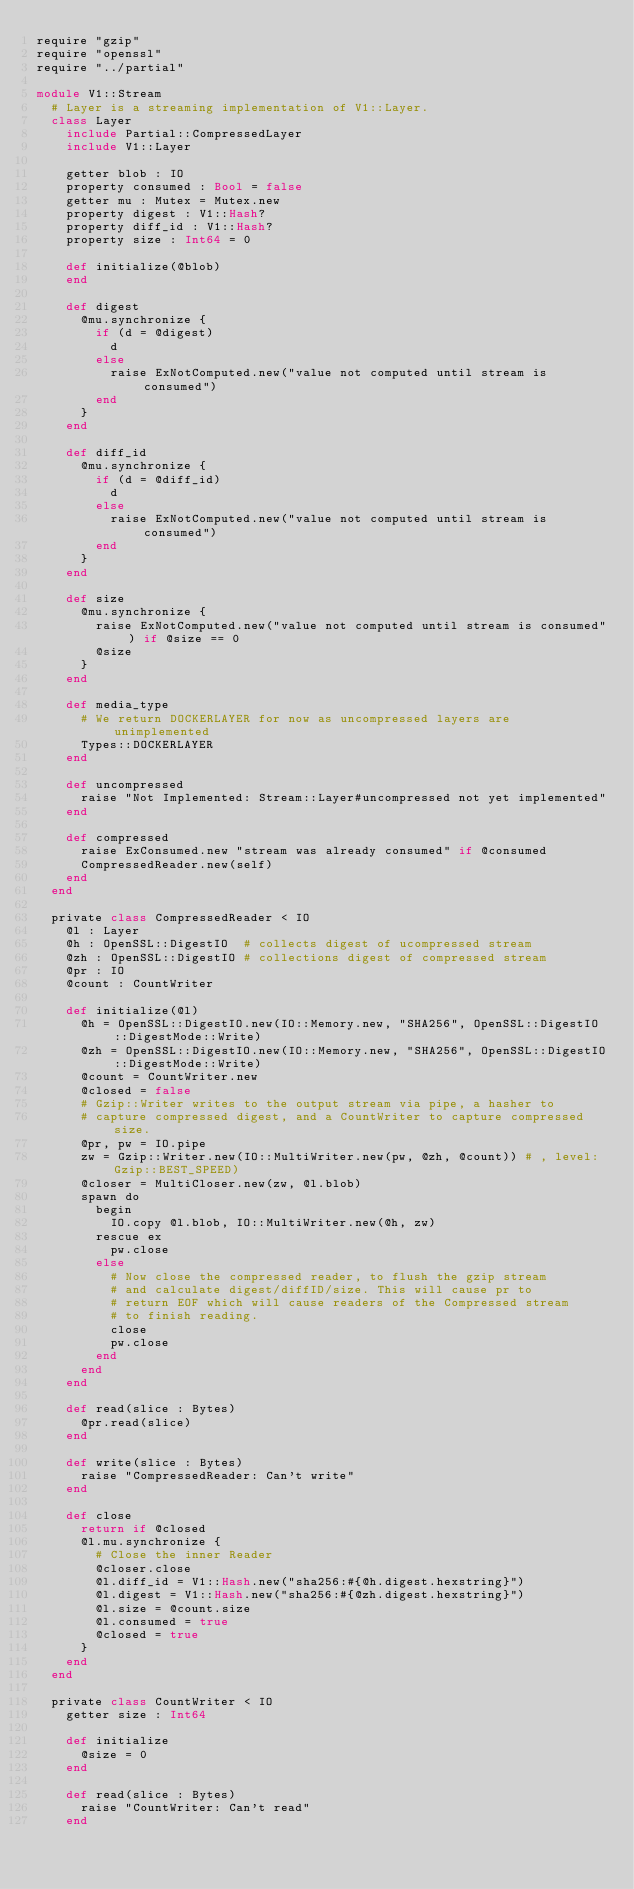Convert code to text. <code><loc_0><loc_0><loc_500><loc_500><_Crystal_>require "gzip"
require "openssl"
require "../partial"

module V1::Stream
  # Layer is a streaming implementation of V1::Layer.
  class Layer
    include Partial::CompressedLayer
    include V1::Layer

    getter blob : IO
    property consumed : Bool = false
    getter mu : Mutex = Mutex.new
    property digest : V1::Hash?
    property diff_id : V1::Hash?
    property size : Int64 = 0

    def initialize(@blob)
    end

    def digest
      @mu.synchronize {
        if (d = @digest)
          d
        else
          raise ExNotComputed.new("value not computed until stream is consumed")
        end
      }
    end

    def diff_id
      @mu.synchronize {
        if (d = @diff_id)
          d
        else
          raise ExNotComputed.new("value not computed until stream is consumed")
        end
      }
    end

    def size
      @mu.synchronize {
        raise ExNotComputed.new("value not computed until stream is consumed") if @size == 0
        @size
      }
    end

    def media_type
      # We return DOCKERLAYER for now as uncompressed layers are unimplemented
      Types::DOCKERLAYER
    end

    def uncompressed
      raise "Not Implemented: Stream::Layer#uncompressed not yet implemented"
    end

    def compressed
      raise ExConsumed.new "stream was already consumed" if @consumed
      CompressedReader.new(self)
    end
  end

  private class CompressedReader < IO
    @l : Layer
    @h : OpenSSL::DigestIO  # collects digest of ucompressed stream
    @zh : OpenSSL::DigestIO # collections digest of compressed stream
    @pr : IO
    @count : CountWriter

    def initialize(@l)
      @h = OpenSSL::DigestIO.new(IO::Memory.new, "SHA256", OpenSSL::DigestIO::DigestMode::Write)
      @zh = OpenSSL::DigestIO.new(IO::Memory.new, "SHA256", OpenSSL::DigestIO::DigestMode::Write)
      @count = CountWriter.new
      @closed = false
      # Gzip::Writer writes to the output stream via pipe, a hasher to
      # capture compressed digest, and a CountWriter to capture compressed size.
      @pr, pw = IO.pipe
      zw = Gzip::Writer.new(IO::MultiWriter.new(pw, @zh, @count)) # , level: Gzip::BEST_SPEED)
      @closer = MultiCloser.new(zw, @l.blob)
      spawn do
        begin
          IO.copy @l.blob, IO::MultiWriter.new(@h, zw)
        rescue ex
          pw.close
        else
          # Now close the compressed reader, to flush the gzip stream
          # and calculate digest/diffID/size. This will cause pr to
          # return EOF which will cause readers of the Compressed stream
          # to finish reading.
          close
          pw.close
        end
      end
    end

    def read(slice : Bytes)
      @pr.read(slice)
    end

    def write(slice : Bytes)
      raise "CompressedReader: Can't write"
    end

    def close
      return if @closed
      @l.mu.synchronize {
        # Close the inner Reader
        @closer.close
        @l.diff_id = V1::Hash.new("sha256:#{@h.digest.hexstring}")
        @l.digest = V1::Hash.new("sha256:#{@zh.digest.hexstring}")
        @l.size = @count.size
        @l.consumed = true
        @closed = true
      }
    end
  end

  private class CountWriter < IO
    getter size : Int64

    def initialize
      @size = 0
    end

    def read(slice : Bytes)
      raise "CountWriter: Can't read"
    end
</code> 